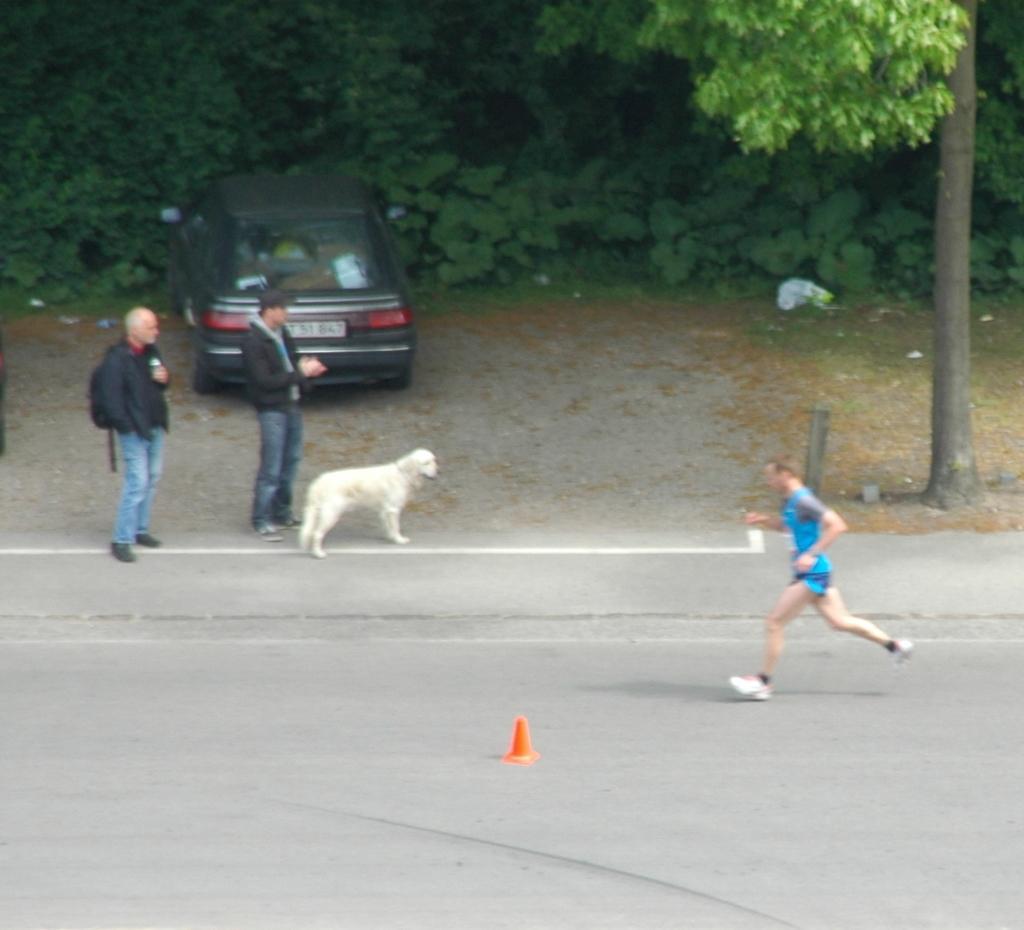Can you describe this image briefly? In this image we see a person running on the road and to the side we can see two people standing and there is a dog. We can see some plants and trees in the background and there is a car. 